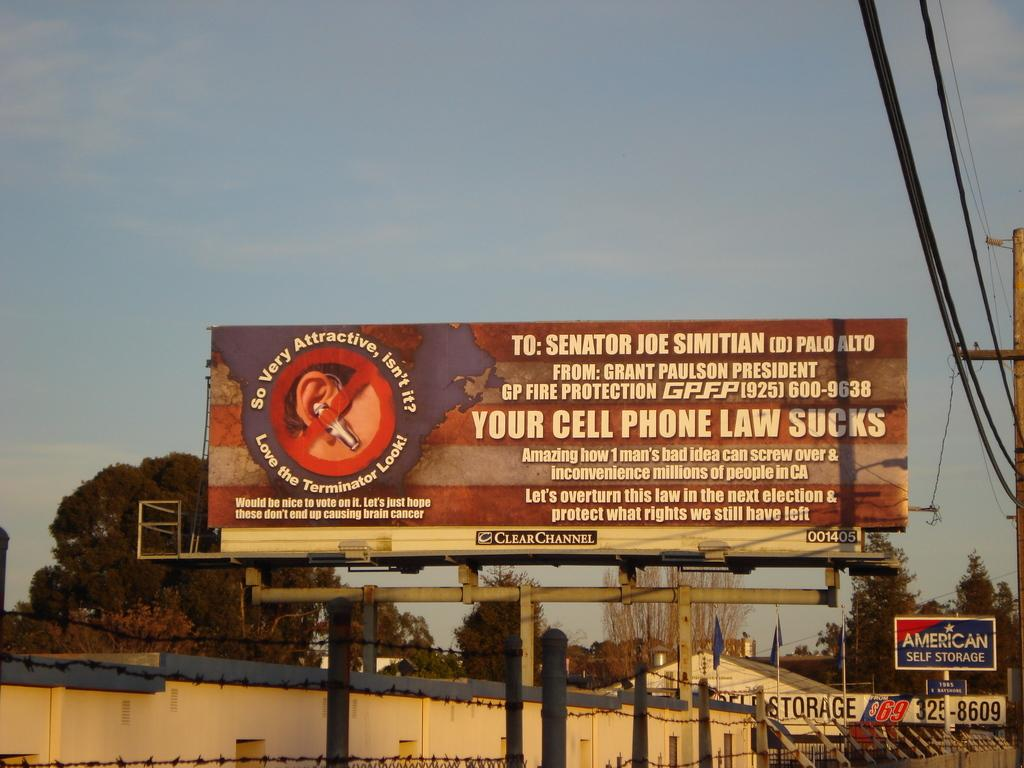Provide a one-sentence caption for the provided image. A ROADSIDE BILLBOARD REGARDING CELL PHONE USAGE LAWS. 